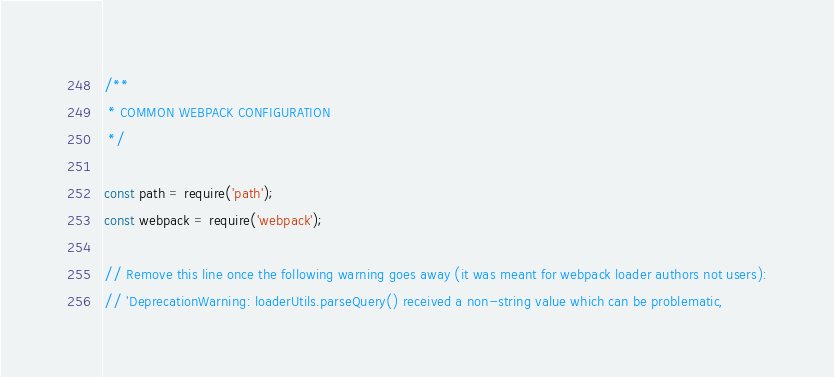<code> <loc_0><loc_0><loc_500><loc_500><_JavaScript_>/**
 * COMMON WEBPACK CONFIGURATION
 */

const path = require('path');
const webpack = require('webpack');

// Remove this line once the following warning goes away (it was meant for webpack loader authors not users):
// 'DeprecationWarning: loaderUtils.parseQuery() received a non-string value which can be problematic,</code> 